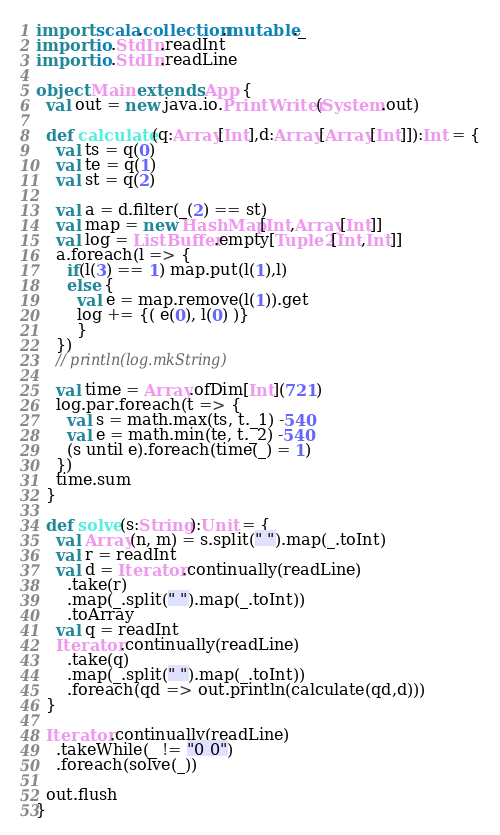Convert code to text. <code><loc_0><loc_0><loc_500><loc_500><_Scala_>import scala.collection.mutable._
import io.StdIn.readInt
import io.StdIn.readLine

object Main extends App {
  val out = new java.io.PrintWriter(System.out)

  def calculate(q:Array[Int],d:Array[Array[Int]]):Int = {
    val ts = q(0)
    val te = q(1)
    val st = q(2)

    val a = d.filter(_(2) == st)
    val map = new HashMap[Int,Array[Int]]
    val log = ListBuffer.empty[Tuple2[Int,Int]]
    a.foreach(l => {
      if(l(3) == 1) map.put(l(1),l)
      else {
        val e = map.remove(l(1)).get
        log += {( e(0), l(0) )}
        }
    })
    // println(log.mkString)

    val time = Array.ofDim[Int](721)
    log.par.foreach(t => {
      val s = math.max(ts, t._1) -540
      val e = math.min(te, t._2) -540
      (s until e).foreach(time(_) = 1)
    })
    time.sum
  }

  def solve(s:String):Unit = {
    val Array(n, m) = s.split(" ").map(_.toInt)
    val r = readInt
    val d = Iterator.continually(readLine)
      .take(r)
      .map(_.split(" ").map(_.toInt))
      .toArray
    val q = readInt
    Iterator.continually(readLine)
      .take(q)
      .map(_.split(" ").map(_.toInt))
      .foreach(qd => out.println(calculate(qd,d)))
  }

  Iterator.continually(readLine)
    .takeWhile(_ != "0 0")
    .foreach(solve(_))
  
  out.flush
}
</code> 